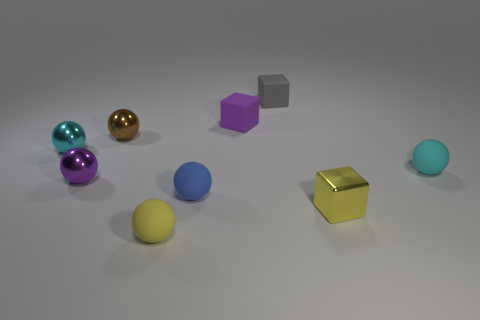The matte ball that is the same color as the tiny shiny cube is what size?
Give a very brief answer. Small. The yellow thing that is to the right of the small yellow sphere has what shape?
Provide a short and direct response. Cube. Are there any rubber spheres that have the same color as the tiny metal block?
Provide a succinct answer. Yes. Is the number of matte things that are in front of the tiny purple ball greater than the number of tiny brown metal balls that are in front of the tiny yellow shiny cube?
Keep it short and to the point. Yes. Is there a small yellow block made of the same material as the blue thing?
Your response must be concise. No. There is a object that is in front of the small gray rubber thing and behind the tiny brown metallic sphere; what material is it?
Give a very brief answer. Rubber. The metallic cube has what color?
Provide a short and direct response. Yellow. How many other blue rubber objects have the same shape as the blue rubber thing?
Offer a very short reply. 0. Is the purple object behind the purple ball made of the same material as the purple object in front of the small purple rubber thing?
Offer a very short reply. No. There is a yellow object in front of the block in front of the small purple ball; how big is it?
Ensure brevity in your answer.  Small. 